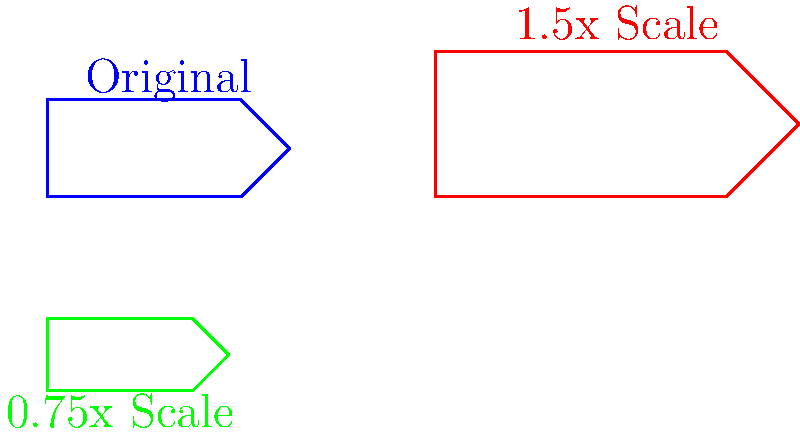A typical Nordic fishing boat design is being scaled for different purposes. The original design has a length of 20 meters and a width of 10 meters. If the boat is scaled up by a factor of 1.5 for commercial fishing, and scaled down by a factor of 0.75 for recreational use, what is the difference in area between the commercial and recreational versions of the boat? Let's approach this step-by-step:

1. Calculate the area of the original boat:
   Area = Length × Width
   $A_{original} = 20 \text{ m} \times 10 \text{ m} = 200 \text{ m}^2$

2. For the commercial boat (scaled up by 1.5):
   New Length = $20 \text{ m} \times 1.5 = 30 \text{ m}$
   New Width = $10 \text{ m} \times 1.5 = 15 \text{ m}$
   $A_{commercial} = 30 \text{ m} \times 15 \text{ m} = 450 \text{ m}^2$

3. For the recreational boat (scaled down by 0.75):
   New Length = $20 \text{ m} \times 0.75 = 15 \text{ m}$
   New Width = $10 \text{ m} \times 0.75 = 7.5 \text{ m}$
   $A_{recreational} = 15 \text{ m} \times 7.5 \text{ m} = 112.5 \text{ m}^2$

4. Calculate the difference in area:
   Difference = $A_{commercial} - A_{recreational}$
   $= 450 \text{ m}^2 - 112.5 \text{ m}^2 = 337.5 \text{ m}^2$
Answer: 337.5 m² 